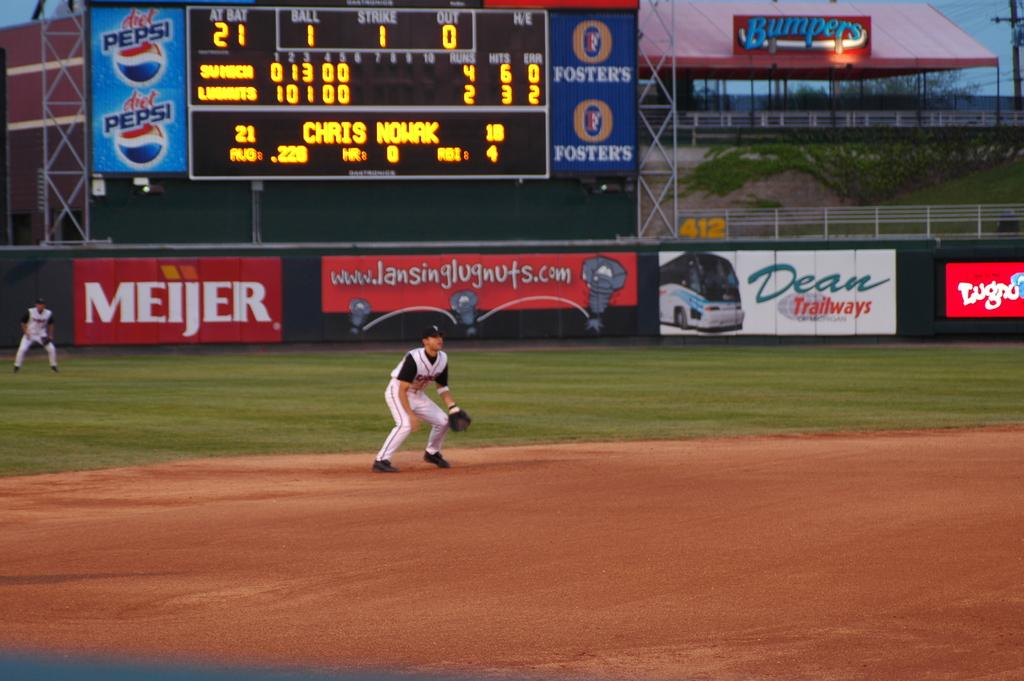<image>
Offer a succinct explanation of the picture presented. A baseball player is ready for a ball with a Meijer and Pepsi advertisement in the background. 